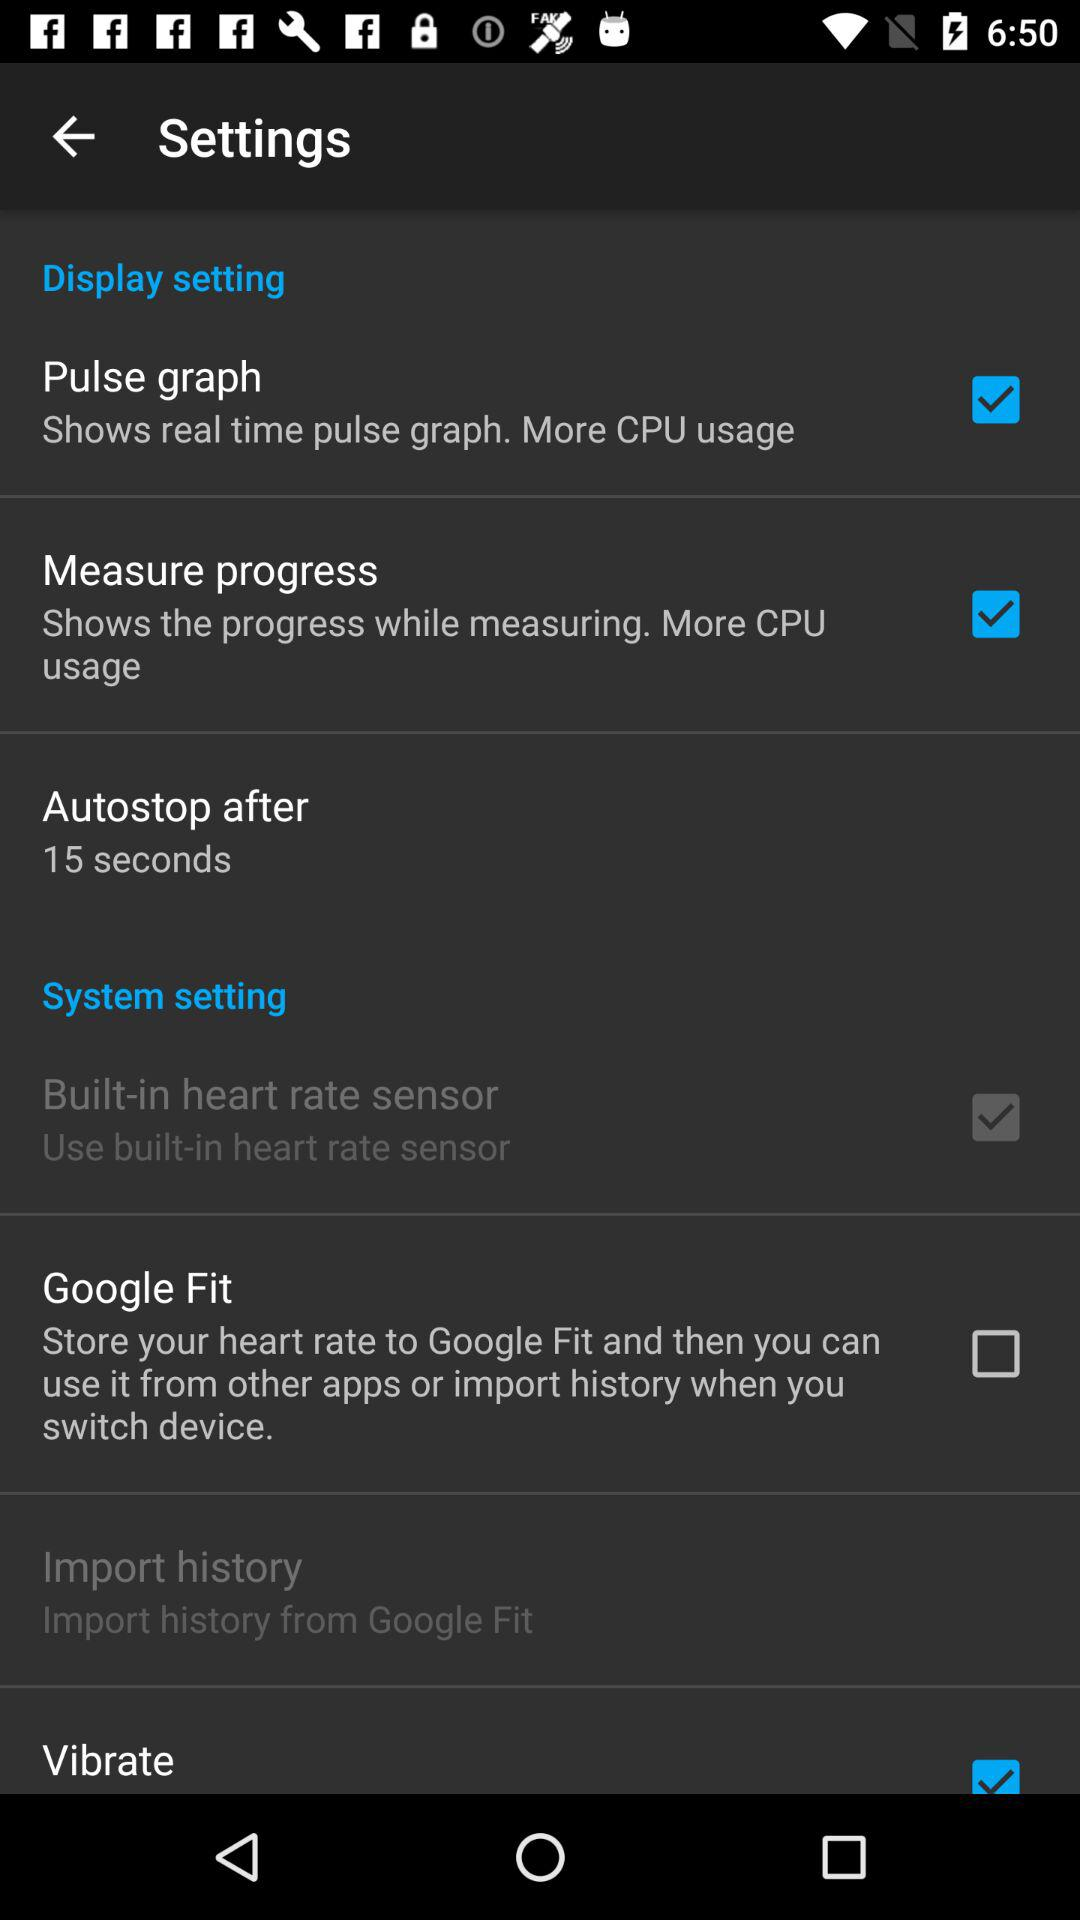Which settings are checked? The checked settings are "Pulse graph", "Measure progress", "Built-in heart rate sensor" and "Vibrate". 